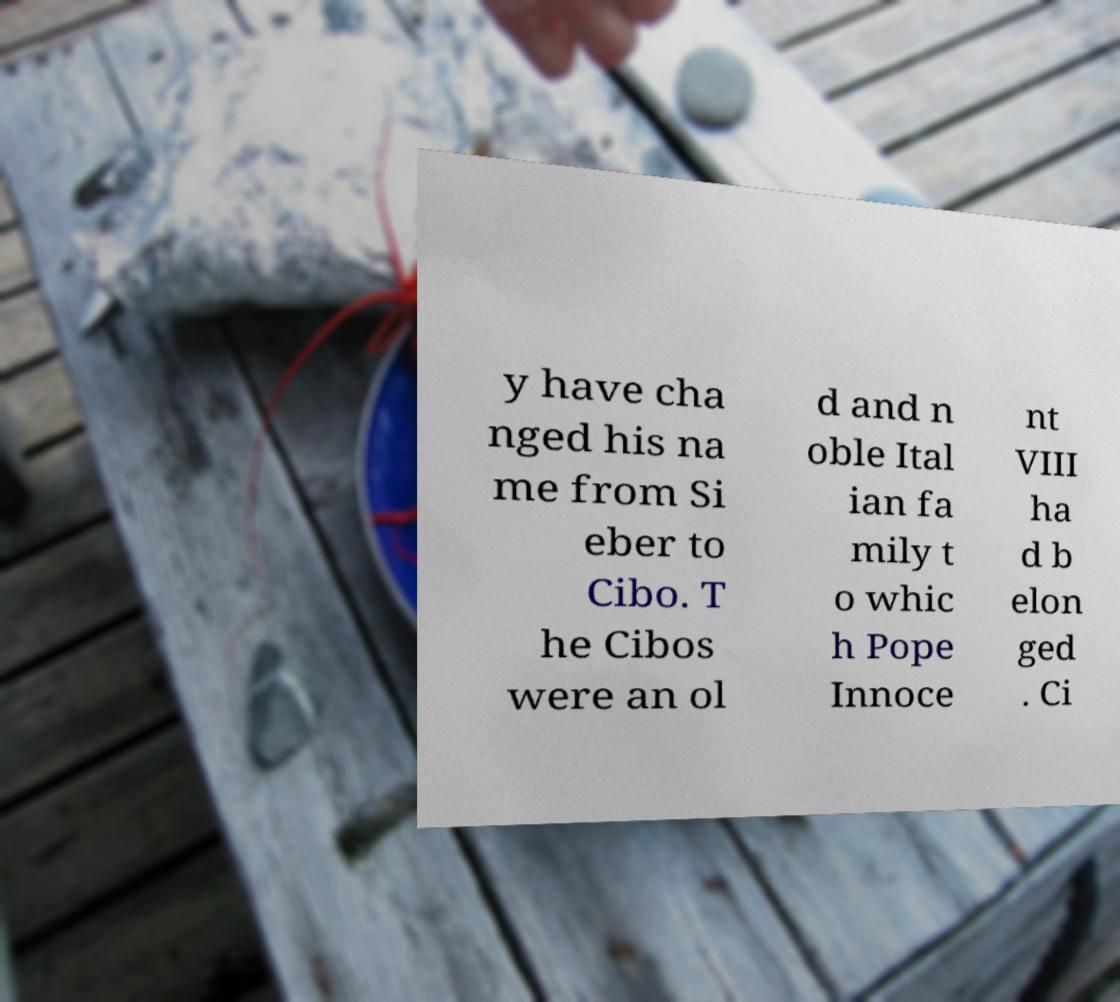Can you accurately transcribe the text from the provided image for me? y have cha nged his na me from Si eber to Cibo. T he Cibos were an ol d and n oble Ital ian fa mily t o whic h Pope Innoce nt VIII ha d b elon ged . Ci 